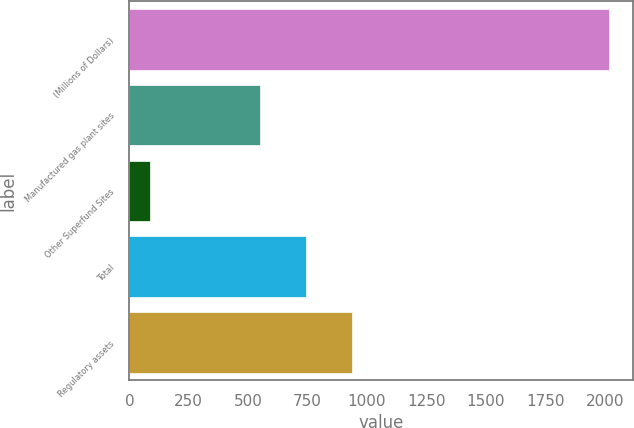Convert chart to OTSL. <chart><loc_0><loc_0><loc_500><loc_500><bar_chart><fcel>(Millions of Dollars)<fcel>Manufactured gas plant sites<fcel>Other Superfund Sites<fcel>Total<fcel>Regulatory assets<nl><fcel>2017<fcel>551<fcel>86<fcel>744.1<fcel>937.2<nl></chart> 